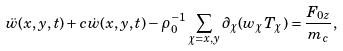<formula> <loc_0><loc_0><loc_500><loc_500>\ddot { w } ( x , y , t ) + c \dot { w } ( x , y , t ) - \rho _ { 0 } ^ { - 1 } \sum _ { \chi = x , y } \partial _ { \chi } ( w _ { \chi } T _ { \chi } ) = \frac { F _ { 0 z } } { m _ { c } } ,</formula> 